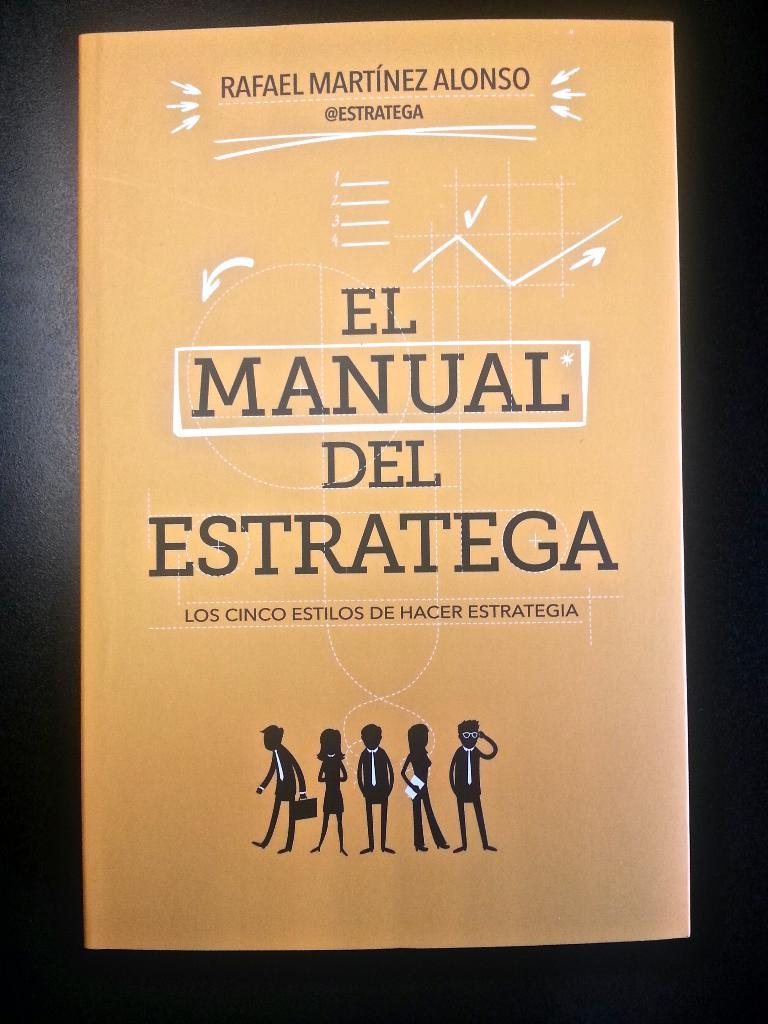<image>
Share a concise interpretation of the image provided. A book titled El Manual Del Estratega featuring little sketches of people at the bottom. 